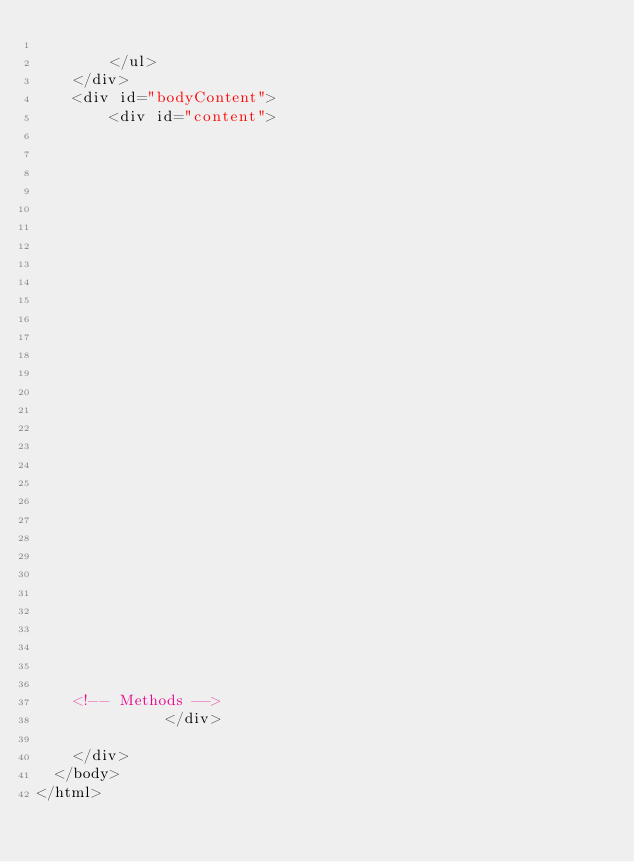Convert code to text. <code><loc_0><loc_0><loc_500><loc_500><_HTML_>            
        </ul>
    </div>
    <div id="bodyContent">
        <div id="content">
  


  


  
  


  


  

  



  

    

    

    


    


    <!-- Methods -->
              </div>

    </div>
  </body>
</html>    </code> 